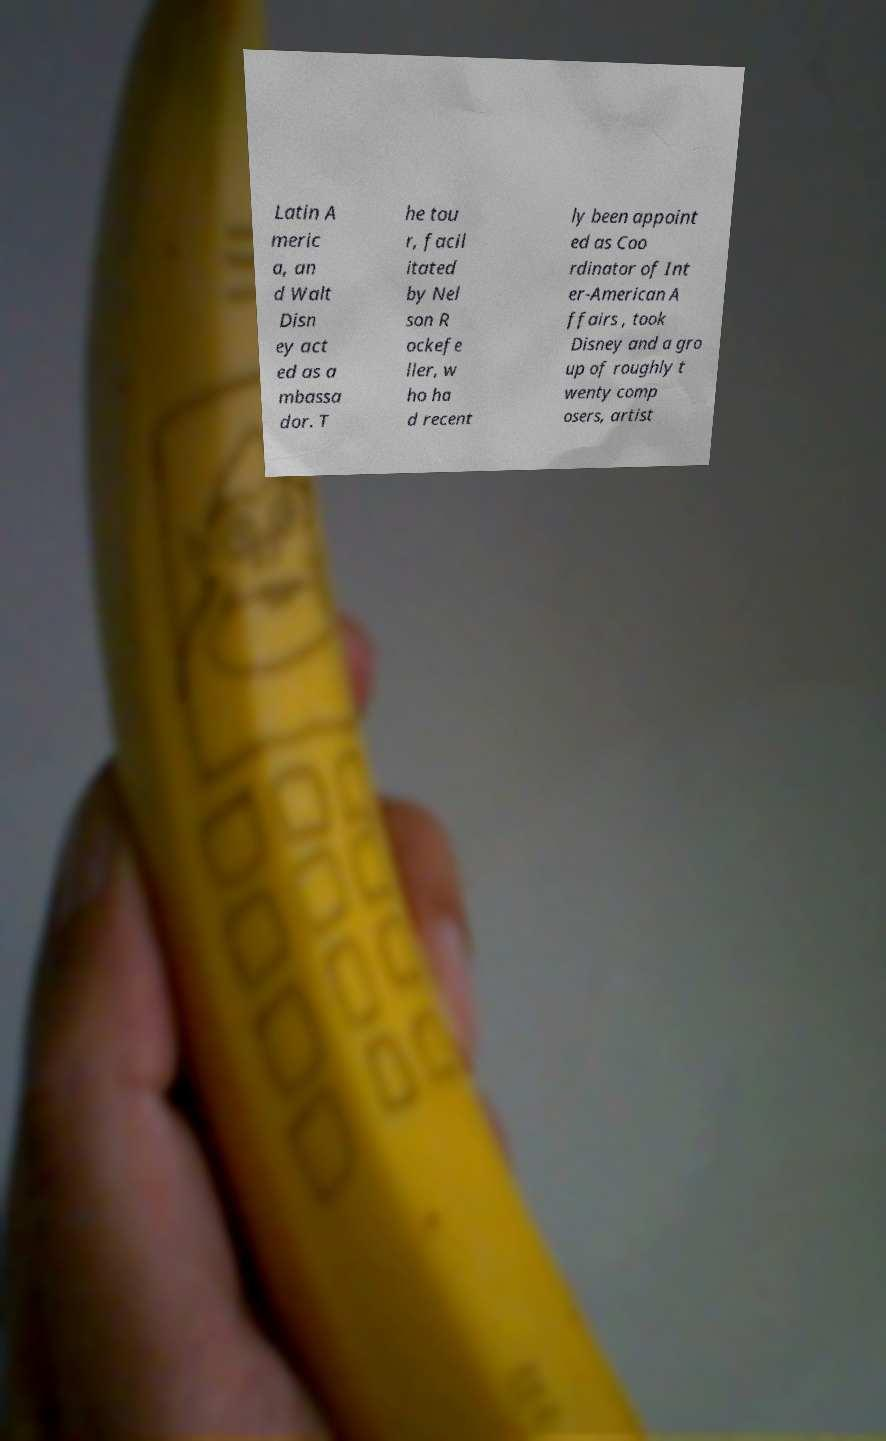I need the written content from this picture converted into text. Can you do that? Latin A meric a, an d Walt Disn ey act ed as a mbassa dor. T he tou r, facil itated by Nel son R ockefe ller, w ho ha d recent ly been appoint ed as Coo rdinator of Int er-American A ffairs , took Disney and a gro up of roughly t wenty comp osers, artist 